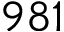Convert formula to latex. <formula><loc_0><loc_0><loc_500><loc_500>9 8 1</formula> 